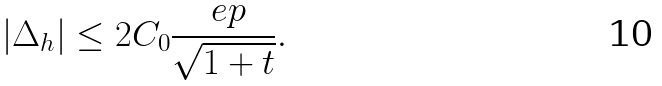Convert formula to latex. <formula><loc_0><loc_0><loc_500><loc_500>| \Delta _ { h } | \leq 2 C _ { 0 } \frac { \ e p } { \sqrt { 1 + t } } .</formula> 